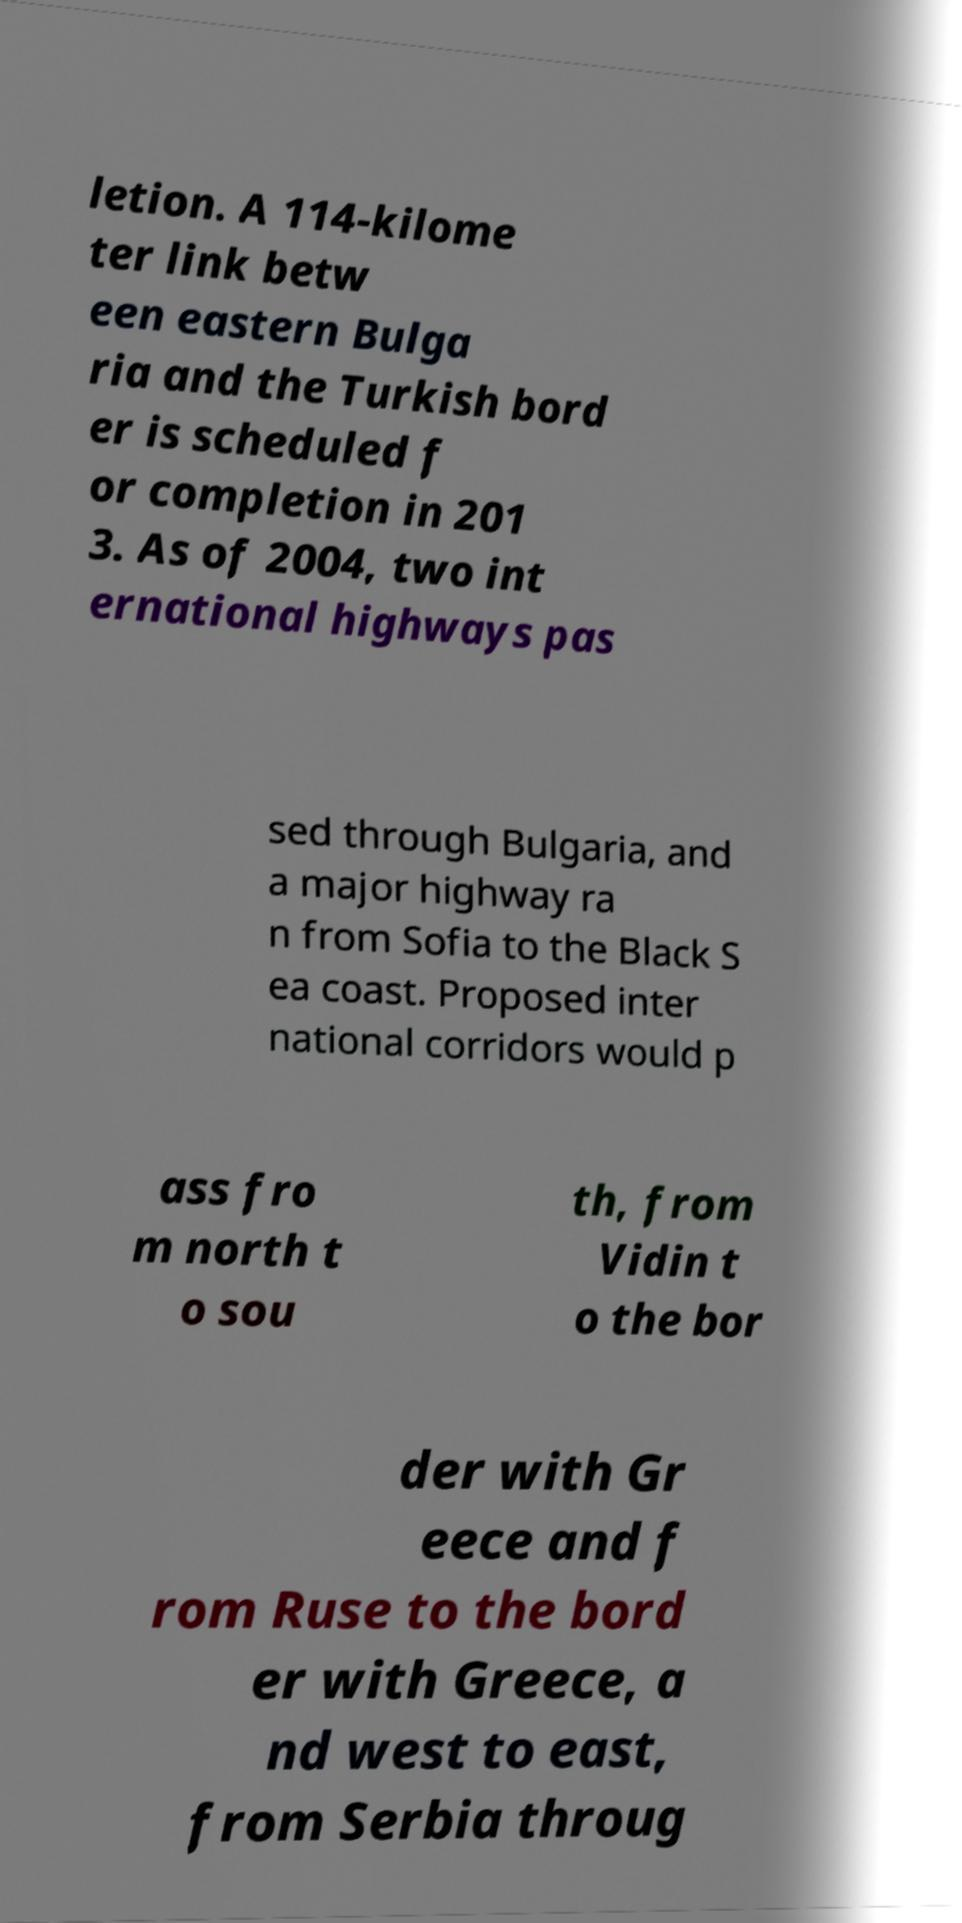What messages or text are displayed in this image? I need them in a readable, typed format. letion. A 114-kilome ter link betw een eastern Bulga ria and the Turkish bord er is scheduled f or completion in 201 3. As of 2004, two int ernational highways pas sed through Bulgaria, and a major highway ra n from Sofia to the Black S ea coast. Proposed inter national corridors would p ass fro m north t o sou th, from Vidin t o the bor der with Gr eece and f rom Ruse to the bord er with Greece, a nd west to east, from Serbia throug 